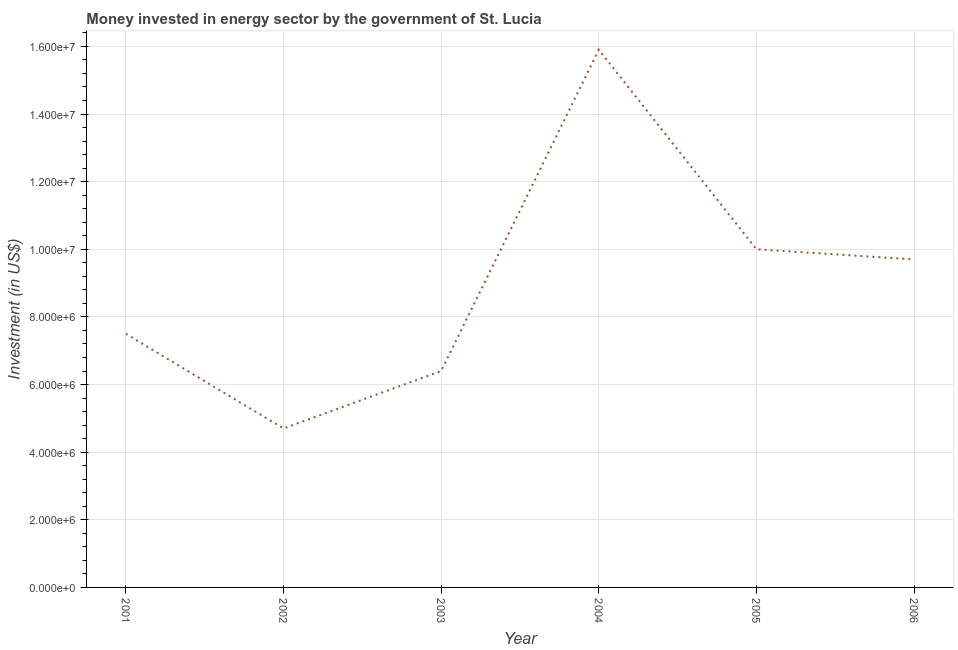What is the investment in energy in 2004?
Provide a short and direct response. 1.59e+07. Across all years, what is the maximum investment in energy?
Your answer should be compact. 1.59e+07. Across all years, what is the minimum investment in energy?
Offer a terse response. 4.70e+06. What is the sum of the investment in energy?
Make the answer very short. 5.42e+07. What is the difference between the investment in energy in 2003 and 2005?
Ensure brevity in your answer.  -3.60e+06. What is the average investment in energy per year?
Your response must be concise. 9.03e+06. What is the median investment in energy?
Offer a terse response. 8.60e+06. What is the ratio of the investment in energy in 2003 to that in 2006?
Your answer should be very brief. 0.66. What is the difference between the highest and the second highest investment in energy?
Provide a succinct answer. 5.90e+06. What is the difference between the highest and the lowest investment in energy?
Provide a short and direct response. 1.12e+07. In how many years, is the investment in energy greater than the average investment in energy taken over all years?
Make the answer very short. 3. Does the investment in energy monotonically increase over the years?
Your response must be concise. No. Does the graph contain any zero values?
Ensure brevity in your answer.  No. What is the title of the graph?
Give a very brief answer. Money invested in energy sector by the government of St. Lucia. What is the label or title of the X-axis?
Offer a terse response. Year. What is the label or title of the Y-axis?
Offer a terse response. Investment (in US$). What is the Investment (in US$) in 2001?
Offer a terse response. 7.50e+06. What is the Investment (in US$) of 2002?
Offer a terse response. 4.70e+06. What is the Investment (in US$) in 2003?
Provide a short and direct response. 6.40e+06. What is the Investment (in US$) of 2004?
Offer a terse response. 1.59e+07. What is the Investment (in US$) in 2005?
Offer a terse response. 1.00e+07. What is the Investment (in US$) in 2006?
Offer a terse response. 9.70e+06. What is the difference between the Investment (in US$) in 2001 and 2002?
Give a very brief answer. 2.80e+06. What is the difference between the Investment (in US$) in 2001 and 2003?
Provide a short and direct response. 1.10e+06. What is the difference between the Investment (in US$) in 2001 and 2004?
Give a very brief answer. -8.40e+06. What is the difference between the Investment (in US$) in 2001 and 2005?
Offer a very short reply. -2.50e+06. What is the difference between the Investment (in US$) in 2001 and 2006?
Provide a short and direct response. -2.20e+06. What is the difference between the Investment (in US$) in 2002 and 2003?
Provide a short and direct response. -1.70e+06. What is the difference between the Investment (in US$) in 2002 and 2004?
Make the answer very short. -1.12e+07. What is the difference between the Investment (in US$) in 2002 and 2005?
Provide a short and direct response. -5.30e+06. What is the difference between the Investment (in US$) in 2002 and 2006?
Offer a very short reply. -5.00e+06. What is the difference between the Investment (in US$) in 2003 and 2004?
Your response must be concise. -9.50e+06. What is the difference between the Investment (in US$) in 2003 and 2005?
Make the answer very short. -3.60e+06. What is the difference between the Investment (in US$) in 2003 and 2006?
Offer a terse response. -3.30e+06. What is the difference between the Investment (in US$) in 2004 and 2005?
Provide a succinct answer. 5.90e+06. What is the difference between the Investment (in US$) in 2004 and 2006?
Your response must be concise. 6.20e+06. What is the difference between the Investment (in US$) in 2005 and 2006?
Keep it short and to the point. 3.00e+05. What is the ratio of the Investment (in US$) in 2001 to that in 2002?
Offer a terse response. 1.6. What is the ratio of the Investment (in US$) in 2001 to that in 2003?
Ensure brevity in your answer.  1.17. What is the ratio of the Investment (in US$) in 2001 to that in 2004?
Offer a very short reply. 0.47. What is the ratio of the Investment (in US$) in 2001 to that in 2006?
Your answer should be compact. 0.77. What is the ratio of the Investment (in US$) in 2002 to that in 2003?
Provide a short and direct response. 0.73. What is the ratio of the Investment (in US$) in 2002 to that in 2004?
Make the answer very short. 0.3. What is the ratio of the Investment (in US$) in 2002 to that in 2005?
Provide a succinct answer. 0.47. What is the ratio of the Investment (in US$) in 2002 to that in 2006?
Your answer should be very brief. 0.48. What is the ratio of the Investment (in US$) in 2003 to that in 2004?
Offer a terse response. 0.4. What is the ratio of the Investment (in US$) in 2003 to that in 2005?
Make the answer very short. 0.64. What is the ratio of the Investment (in US$) in 2003 to that in 2006?
Provide a short and direct response. 0.66. What is the ratio of the Investment (in US$) in 2004 to that in 2005?
Provide a short and direct response. 1.59. What is the ratio of the Investment (in US$) in 2004 to that in 2006?
Make the answer very short. 1.64. What is the ratio of the Investment (in US$) in 2005 to that in 2006?
Your response must be concise. 1.03. 